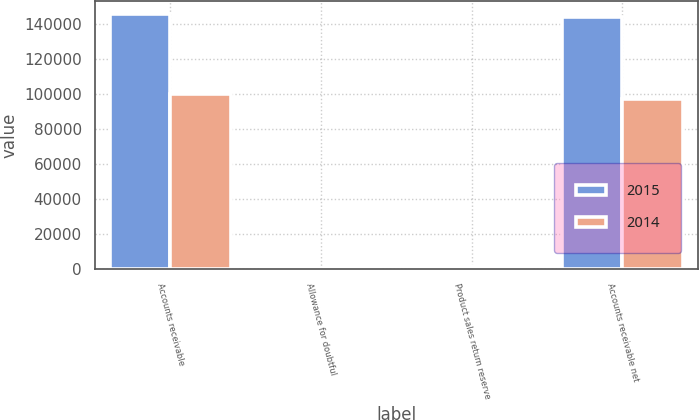<chart> <loc_0><loc_0><loc_500><loc_500><stacked_bar_chart><ecel><fcel>Accounts receivable<fcel>Allowance for doubtful<fcel>Product sales return reserve<fcel>Accounts receivable net<nl><fcel>2015<fcel>145792<fcel>963<fcel>566<fcel>144263<nl><fcel>2014<fcel>100076<fcel>1063<fcel>2031<fcel>96982<nl></chart> 